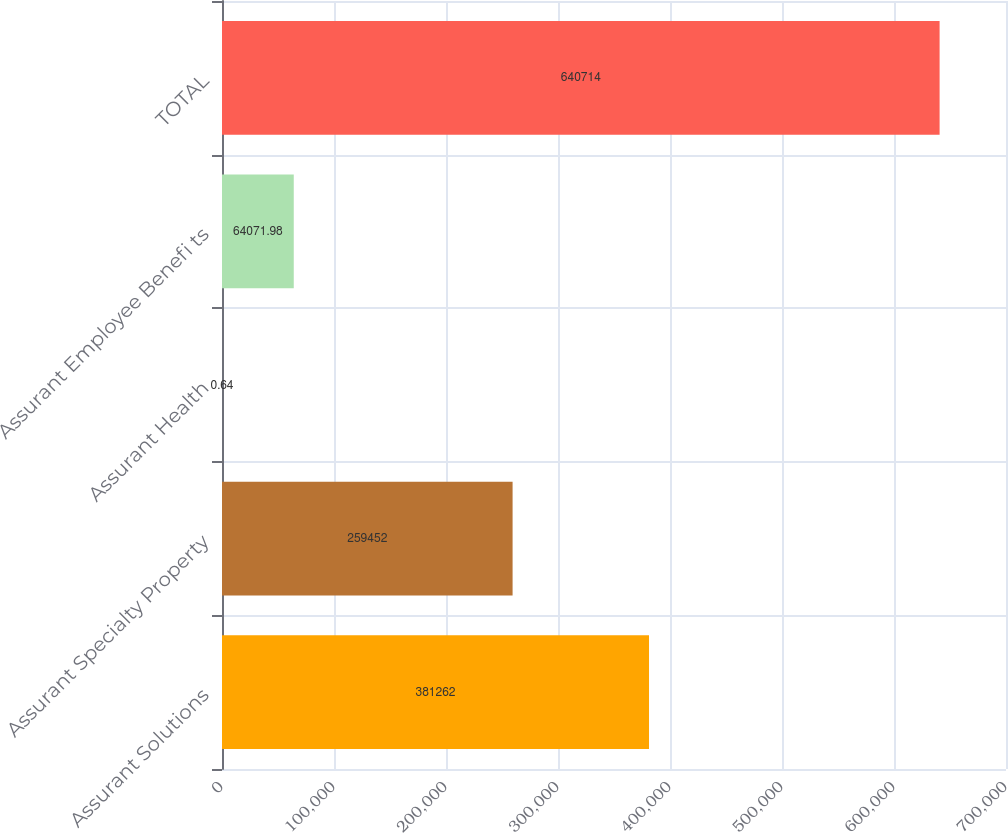<chart> <loc_0><loc_0><loc_500><loc_500><bar_chart><fcel>Assurant Solutions<fcel>Assurant Specialty Property<fcel>Assurant Health<fcel>Assurant Employee Benefi ts<fcel>TOTAL<nl><fcel>381262<fcel>259452<fcel>0.64<fcel>64072<fcel>640714<nl></chart> 